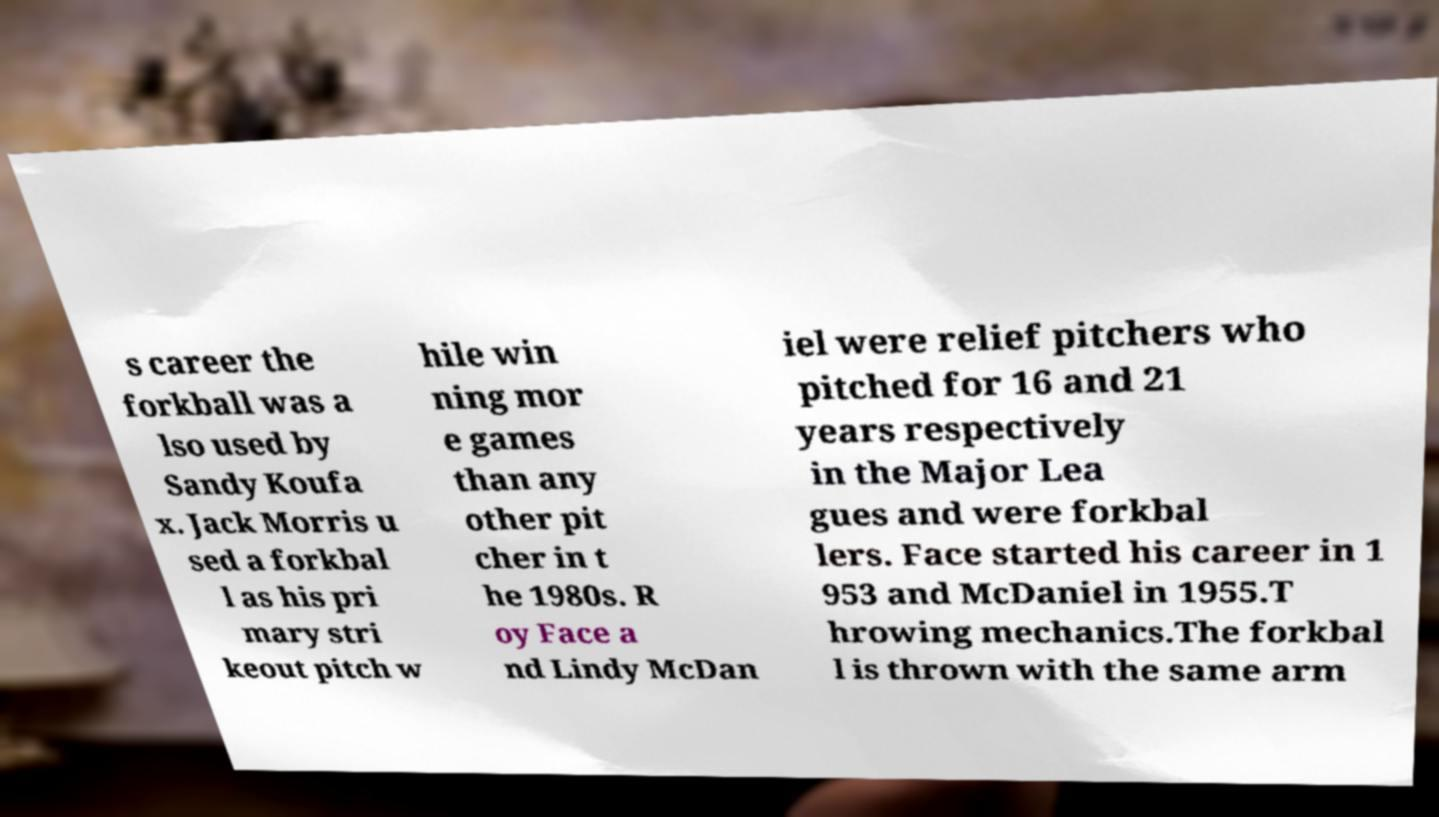Could you assist in decoding the text presented in this image and type it out clearly? s career the forkball was a lso used by Sandy Koufa x. Jack Morris u sed a forkbal l as his pri mary stri keout pitch w hile win ning mor e games than any other pit cher in t he 1980s. R oy Face a nd Lindy McDan iel were relief pitchers who pitched for 16 and 21 years respectively in the Major Lea gues and were forkbal lers. Face started his career in 1 953 and McDaniel in 1955.T hrowing mechanics.The forkbal l is thrown with the same arm 